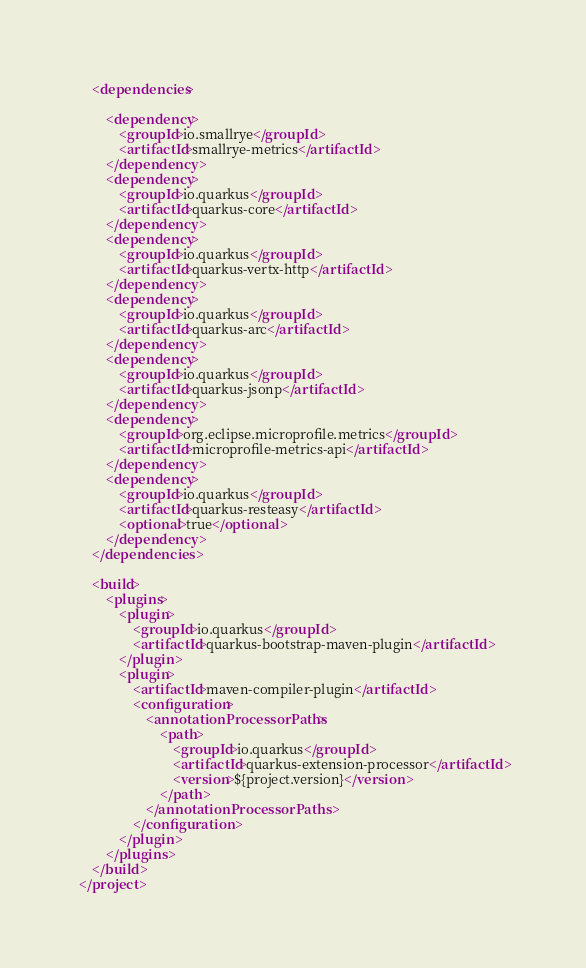Convert code to text. <code><loc_0><loc_0><loc_500><loc_500><_XML_>    <dependencies>

        <dependency>
            <groupId>io.smallrye</groupId>
            <artifactId>smallrye-metrics</artifactId>
        </dependency>
        <dependency>
            <groupId>io.quarkus</groupId>
            <artifactId>quarkus-core</artifactId>
        </dependency>
        <dependency>
            <groupId>io.quarkus</groupId>
            <artifactId>quarkus-vertx-http</artifactId>
        </dependency>
        <dependency>
            <groupId>io.quarkus</groupId>
            <artifactId>quarkus-arc</artifactId>
        </dependency>
        <dependency>
            <groupId>io.quarkus</groupId>
            <artifactId>quarkus-jsonp</artifactId>
        </dependency>
        <dependency>
            <groupId>org.eclipse.microprofile.metrics</groupId>
            <artifactId>microprofile-metrics-api</artifactId>
        </dependency>
        <dependency>
            <groupId>io.quarkus</groupId>
            <artifactId>quarkus-resteasy</artifactId>
            <optional>true</optional>
        </dependency>
    </dependencies>

    <build>
        <plugins>
            <plugin>
                <groupId>io.quarkus</groupId>
                <artifactId>quarkus-bootstrap-maven-plugin</artifactId>
            </plugin>
            <plugin>
                <artifactId>maven-compiler-plugin</artifactId>
                <configuration>
                    <annotationProcessorPaths>
                        <path>
                            <groupId>io.quarkus</groupId>
                            <artifactId>quarkus-extension-processor</artifactId>
                            <version>${project.version}</version>
                        </path>
                    </annotationProcessorPaths>
                </configuration>
            </plugin>
        </plugins>
    </build>
</project>
</code> 